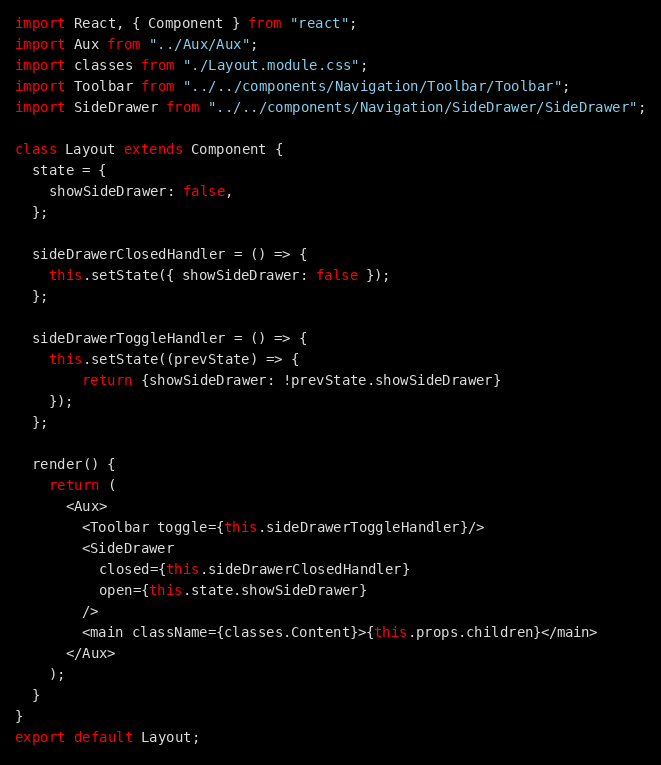<code> <loc_0><loc_0><loc_500><loc_500><_JavaScript_>import React, { Component } from "react";
import Aux from "../Aux/Aux";
import classes from "./Layout.module.css";
import Toolbar from "../../components/Navigation/Toolbar/Toolbar";
import SideDrawer from "../../components/Navigation/SideDrawer/SideDrawer";

class Layout extends Component {
  state = {
    showSideDrawer: false,
  };

  sideDrawerClosedHandler = () => {
    this.setState({ showSideDrawer: false });
  };

  sideDrawerToggleHandler = () => {
    this.setState((prevState) => { 
		return {showSideDrawer: !prevState.showSideDrawer}
	});
  };

  render() {
    return (
      <Aux>
        <Toolbar toggle={this.sideDrawerToggleHandler}/>
        <SideDrawer
          closed={this.sideDrawerClosedHandler}
          open={this.state.showSideDrawer}
        />
        <main className={classes.Content}>{this.props.children}</main>
      </Aux>
    );
  }
}
export default Layout;
</code> 